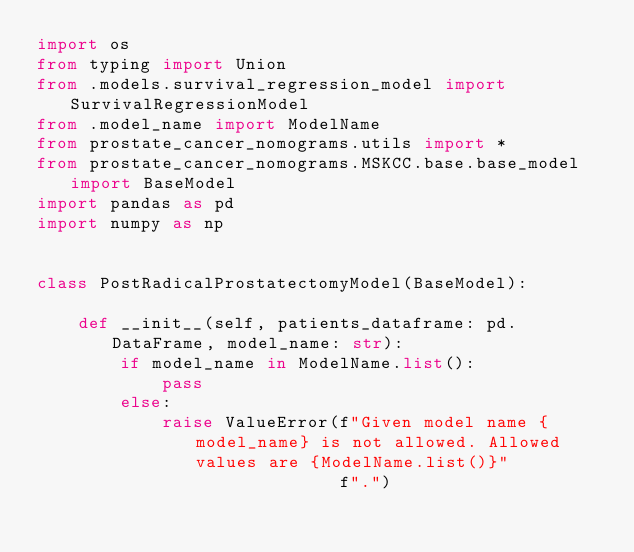<code> <loc_0><loc_0><loc_500><loc_500><_Python_>import os
from typing import Union
from .models.survival_regression_model import SurvivalRegressionModel
from .model_name import ModelName
from prostate_cancer_nomograms.utils import *
from prostate_cancer_nomograms.MSKCC.base.base_model import BaseModel
import pandas as pd
import numpy as np


class PostRadicalProstatectomyModel(BaseModel):

    def __init__(self, patients_dataframe: pd.DataFrame, model_name: str):
        if model_name in ModelName.list():
            pass
        else:
            raise ValueError(f"Given model name {model_name} is not allowed. Allowed values are {ModelName.list()}"
                             f".")
</code> 